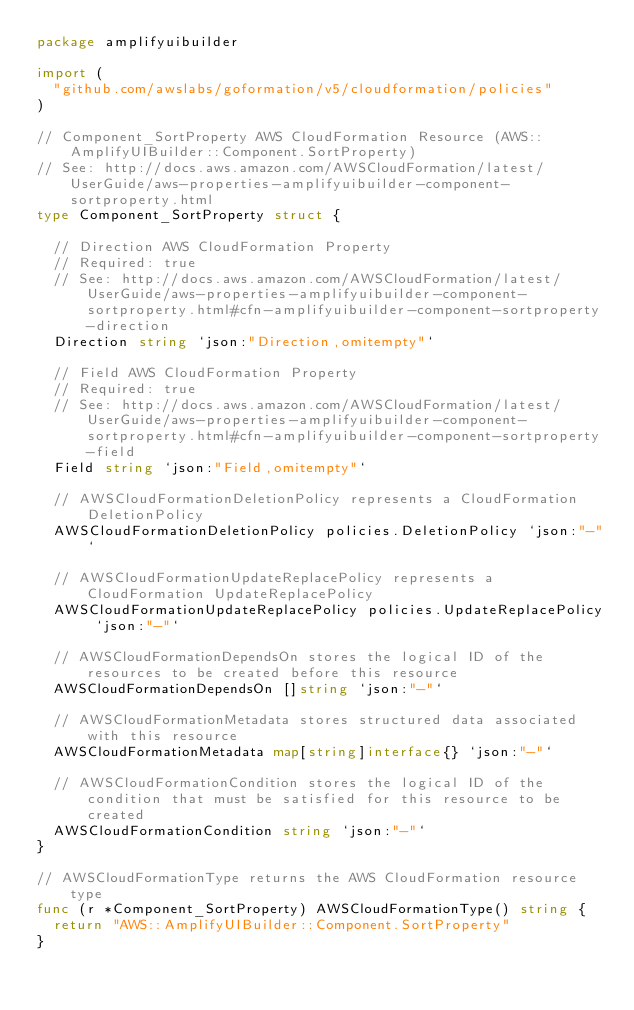Convert code to text. <code><loc_0><loc_0><loc_500><loc_500><_Go_>package amplifyuibuilder

import (
	"github.com/awslabs/goformation/v5/cloudformation/policies"
)

// Component_SortProperty AWS CloudFormation Resource (AWS::AmplifyUIBuilder::Component.SortProperty)
// See: http://docs.aws.amazon.com/AWSCloudFormation/latest/UserGuide/aws-properties-amplifyuibuilder-component-sortproperty.html
type Component_SortProperty struct {

	// Direction AWS CloudFormation Property
	// Required: true
	// See: http://docs.aws.amazon.com/AWSCloudFormation/latest/UserGuide/aws-properties-amplifyuibuilder-component-sortproperty.html#cfn-amplifyuibuilder-component-sortproperty-direction
	Direction string `json:"Direction,omitempty"`

	// Field AWS CloudFormation Property
	// Required: true
	// See: http://docs.aws.amazon.com/AWSCloudFormation/latest/UserGuide/aws-properties-amplifyuibuilder-component-sortproperty.html#cfn-amplifyuibuilder-component-sortproperty-field
	Field string `json:"Field,omitempty"`

	// AWSCloudFormationDeletionPolicy represents a CloudFormation DeletionPolicy
	AWSCloudFormationDeletionPolicy policies.DeletionPolicy `json:"-"`

	// AWSCloudFormationUpdateReplacePolicy represents a CloudFormation UpdateReplacePolicy
	AWSCloudFormationUpdateReplacePolicy policies.UpdateReplacePolicy `json:"-"`

	// AWSCloudFormationDependsOn stores the logical ID of the resources to be created before this resource
	AWSCloudFormationDependsOn []string `json:"-"`

	// AWSCloudFormationMetadata stores structured data associated with this resource
	AWSCloudFormationMetadata map[string]interface{} `json:"-"`

	// AWSCloudFormationCondition stores the logical ID of the condition that must be satisfied for this resource to be created
	AWSCloudFormationCondition string `json:"-"`
}

// AWSCloudFormationType returns the AWS CloudFormation resource type
func (r *Component_SortProperty) AWSCloudFormationType() string {
	return "AWS::AmplifyUIBuilder::Component.SortProperty"
}
</code> 